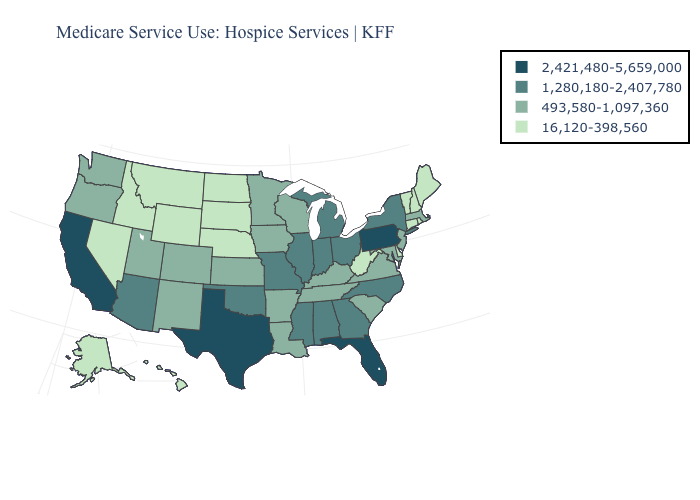Which states have the lowest value in the Northeast?
Give a very brief answer. Connecticut, Maine, New Hampshire, Rhode Island, Vermont. What is the value of New York?
Give a very brief answer. 1,280,180-2,407,780. Does the first symbol in the legend represent the smallest category?
Quick response, please. No. What is the value of Wisconsin?
Answer briefly. 493,580-1,097,360. How many symbols are there in the legend?
Short answer required. 4. Name the states that have a value in the range 1,280,180-2,407,780?
Give a very brief answer. Alabama, Arizona, Georgia, Illinois, Indiana, Michigan, Mississippi, Missouri, New York, North Carolina, Ohio, Oklahoma. Name the states that have a value in the range 16,120-398,560?
Quick response, please. Alaska, Connecticut, Delaware, Hawaii, Idaho, Maine, Montana, Nebraska, Nevada, New Hampshire, North Dakota, Rhode Island, South Dakota, Vermont, West Virginia, Wyoming. Which states have the lowest value in the MidWest?
Quick response, please. Nebraska, North Dakota, South Dakota. What is the value of Florida?
Concise answer only. 2,421,480-5,659,000. Does Virginia have the lowest value in the USA?
Answer briefly. No. Does Minnesota have the highest value in the USA?
Write a very short answer. No. Name the states that have a value in the range 493,580-1,097,360?
Short answer required. Arkansas, Colorado, Iowa, Kansas, Kentucky, Louisiana, Maryland, Massachusetts, Minnesota, New Jersey, New Mexico, Oregon, South Carolina, Tennessee, Utah, Virginia, Washington, Wisconsin. Does the first symbol in the legend represent the smallest category?
Concise answer only. No. Does the first symbol in the legend represent the smallest category?
Short answer required. No. Name the states that have a value in the range 2,421,480-5,659,000?
Give a very brief answer. California, Florida, Pennsylvania, Texas. 